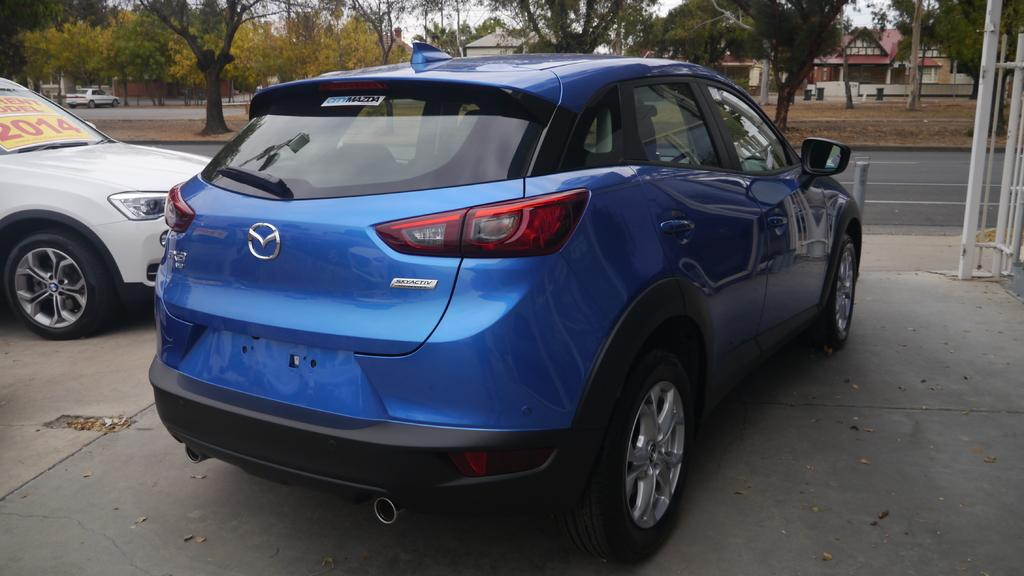What type of structures can be seen in the image? There are houses in the image. What can be seen beside the road in the image? Cars are parked beside the road in the image. What type of vegetation is present in the image? There are trees in the image. What role does the stem play in the image? There is no stem present in the image. Can you identify the actor in the image? There are no actors present in the image. 